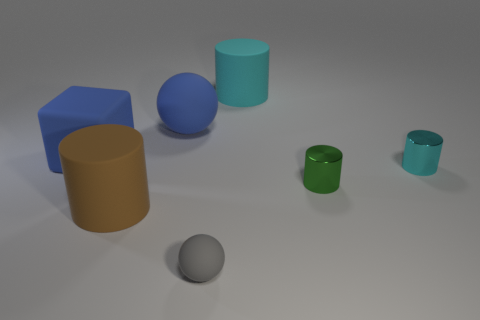Subtract all brown spheres. How many cyan cylinders are left? 2 Subtract all large cyan rubber cylinders. How many cylinders are left? 3 Subtract all brown cylinders. How many cylinders are left? 3 Add 1 small gray spheres. How many objects exist? 8 Subtract all blue cylinders. Subtract all cyan cubes. How many cylinders are left? 4 Subtract all cubes. How many objects are left? 6 Subtract all tiny gray rubber things. Subtract all large brown matte things. How many objects are left? 5 Add 1 big brown rubber cylinders. How many big brown rubber cylinders are left? 2 Add 4 large cyan matte cylinders. How many large cyan matte cylinders exist? 5 Subtract 0 red blocks. How many objects are left? 7 